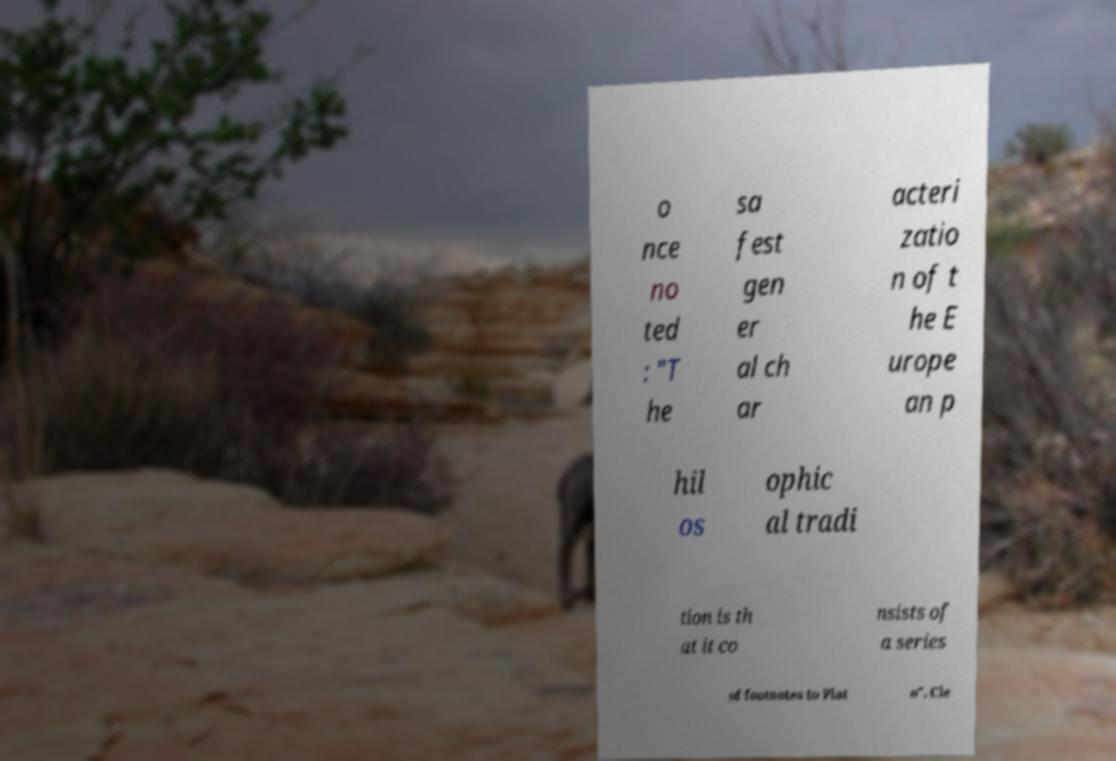Could you extract and type out the text from this image? o nce no ted : "T he sa fest gen er al ch ar acteri zatio n of t he E urope an p hil os ophic al tradi tion is th at it co nsists of a series of footnotes to Plat o". Cle 